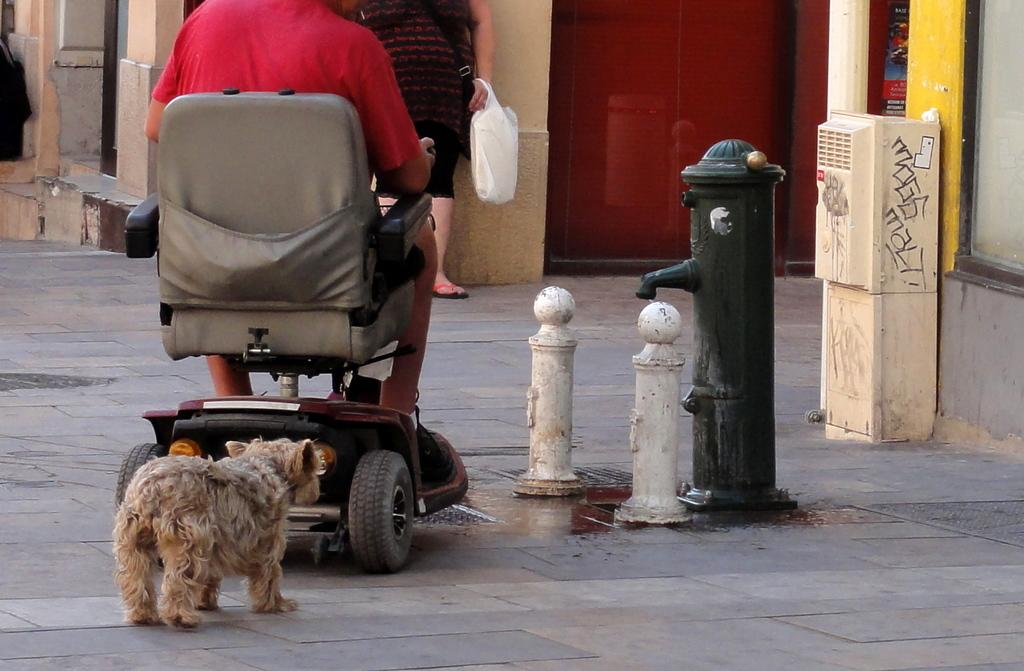What can be seen in the background of the image? There is a wall in the image. What is the woman in the image doing? The woman is standing in the image, holding covers. Can you describe the person sitting in the image? There is a person sitting in the image, wearing a red shirt. What type of animal is present in the image? There is a dog in the image. How does the woman measure the distance between the wall and the dog in the image? There is no indication in the image that the woman is measuring anything, nor is there any measuring tool present. 